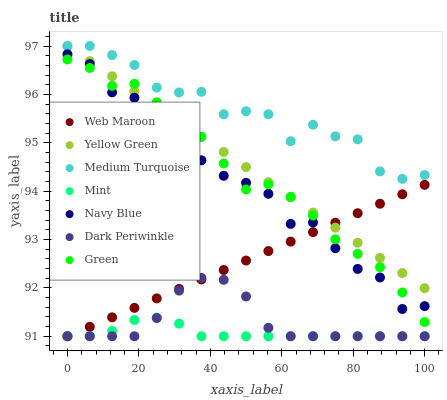Does Mint have the minimum area under the curve?
Answer yes or no. Yes. Does Medium Turquoise have the maximum area under the curve?
Answer yes or no. Yes. Does Navy Blue have the minimum area under the curve?
Answer yes or no. No. Does Navy Blue have the maximum area under the curve?
Answer yes or no. No. Is Yellow Green the smoothest?
Answer yes or no. Yes. Is Medium Turquoise the roughest?
Answer yes or no. Yes. Is Navy Blue the smoothest?
Answer yes or no. No. Is Navy Blue the roughest?
Answer yes or no. No. Does Web Maroon have the lowest value?
Answer yes or no. Yes. Does Navy Blue have the lowest value?
Answer yes or no. No. Does Medium Turquoise have the highest value?
Answer yes or no. Yes. Does Navy Blue have the highest value?
Answer yes or no. No. Is Green less than Medium Turquoise?
Answer yes or no. Yes. Is Medium Turquoise greater than Green?
Answer yes or no. Yes. Does Green intersect Navy Blue?
Answer yes or no. Yes. Is Green less than Navy Blue?
Answer yes or no. No. Is Green greater than Navy Blue?
Answer yes or no. No. Does Green intersect Medium Turquoise?
Answer yes or no. No. 